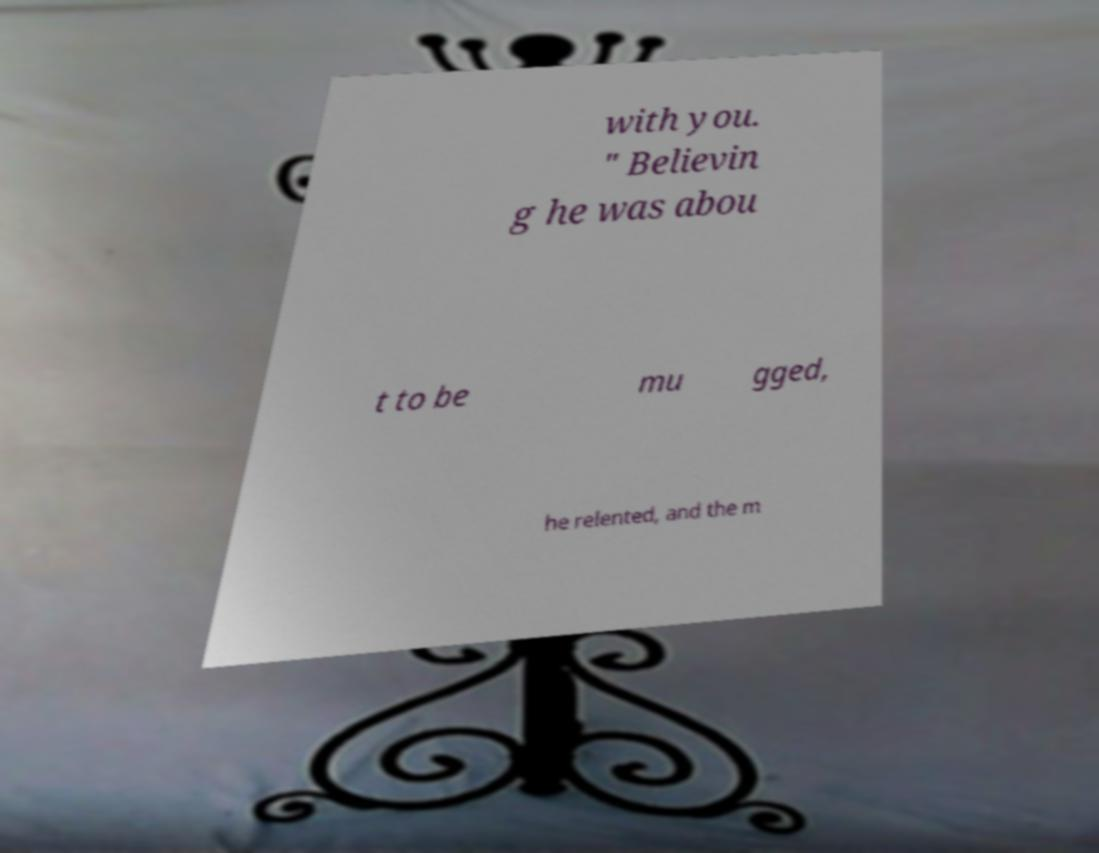I need the written content from this picture converted into text. Can you do that? with you. " Believin g he was abou t to be mu gged, he relented, and the m 